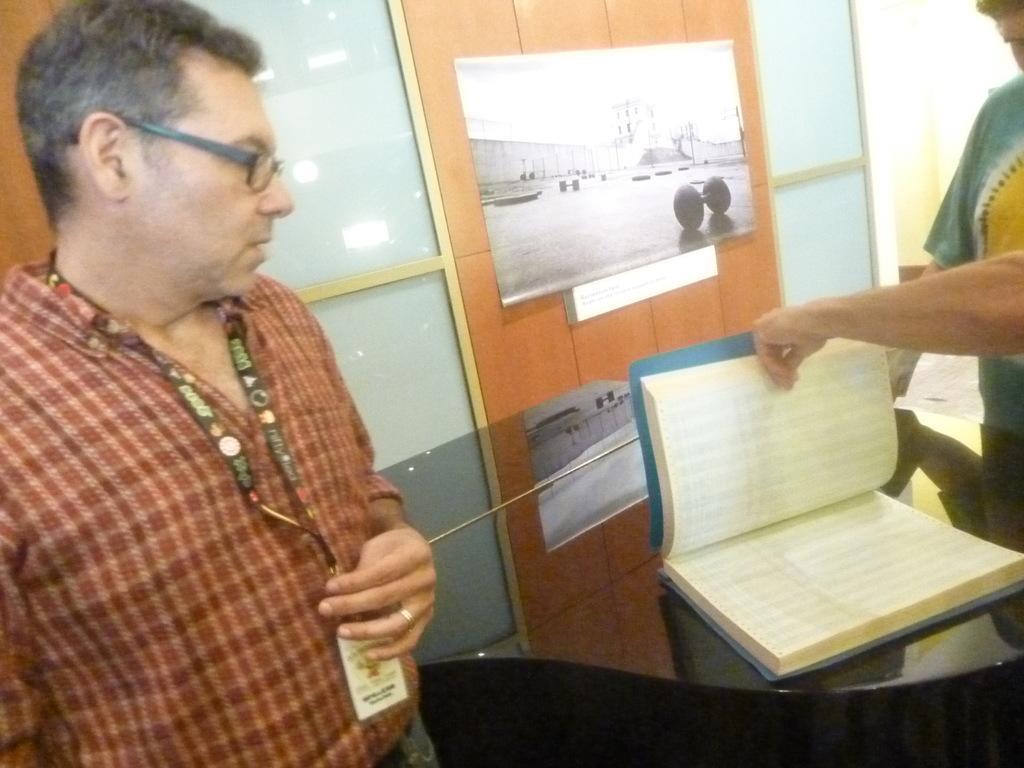In one or two sentences, can you explain what this image depicts? In this image we can see two people are standing, one person with spectacles holding an ID card and another person holding a book on the table. There are some glass windows and some papers stitched in the wooden wall. 